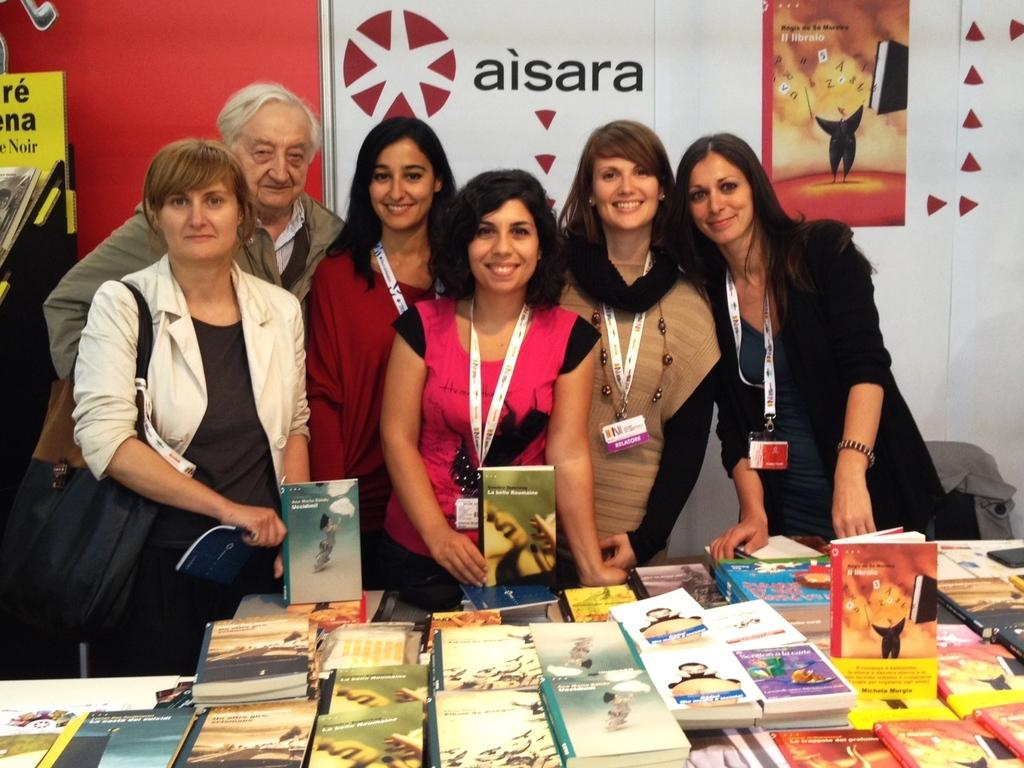<image>
Give a short and clear explanation of the subsequent image. The word aisara can be seen behind woman standing together. 